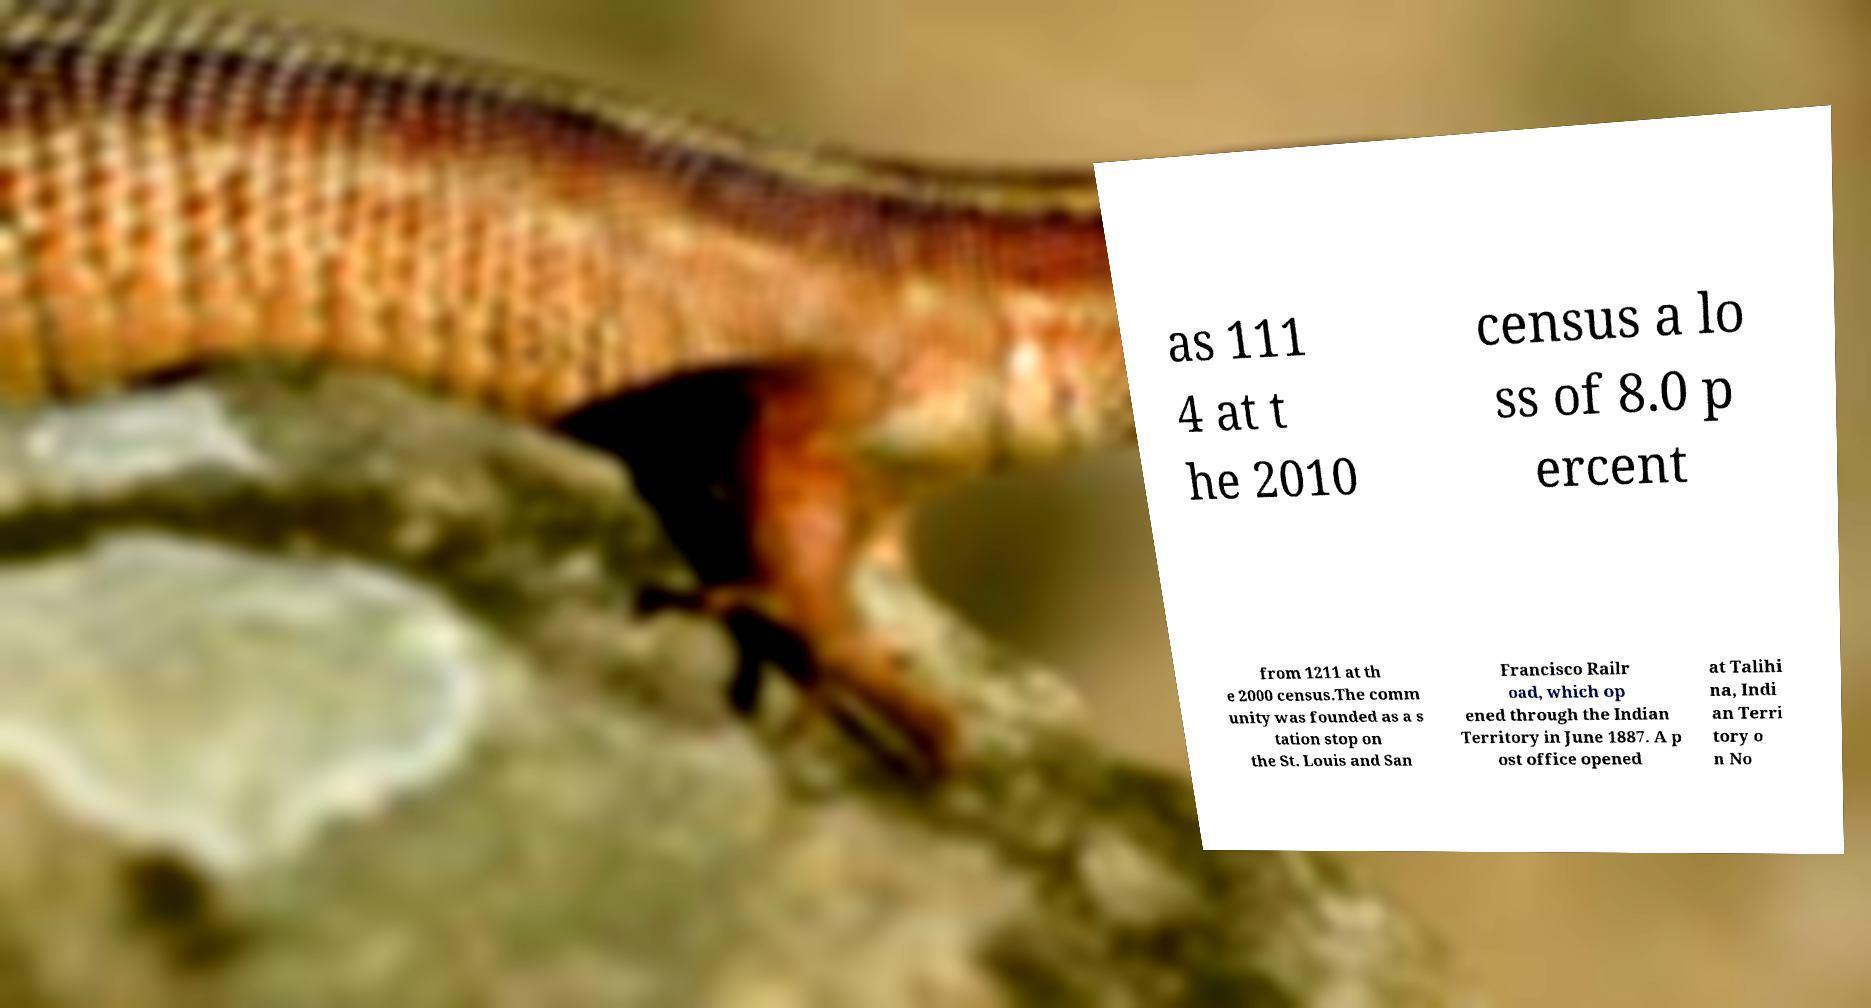For documentation purposes, I need the text within this image transcribed. Could you provide that? as 111 4 at t he 2010 census a lo ss of 8.0 p ercent from 1211 at th e 2000 census.The comm unity was founded as a s tation stop on the St. Louis and San Francisco Railr oad, which op ened through the Indian Territory in June 1887. A p ost office opened at Talihi na, Indi an Terri tory o n No 